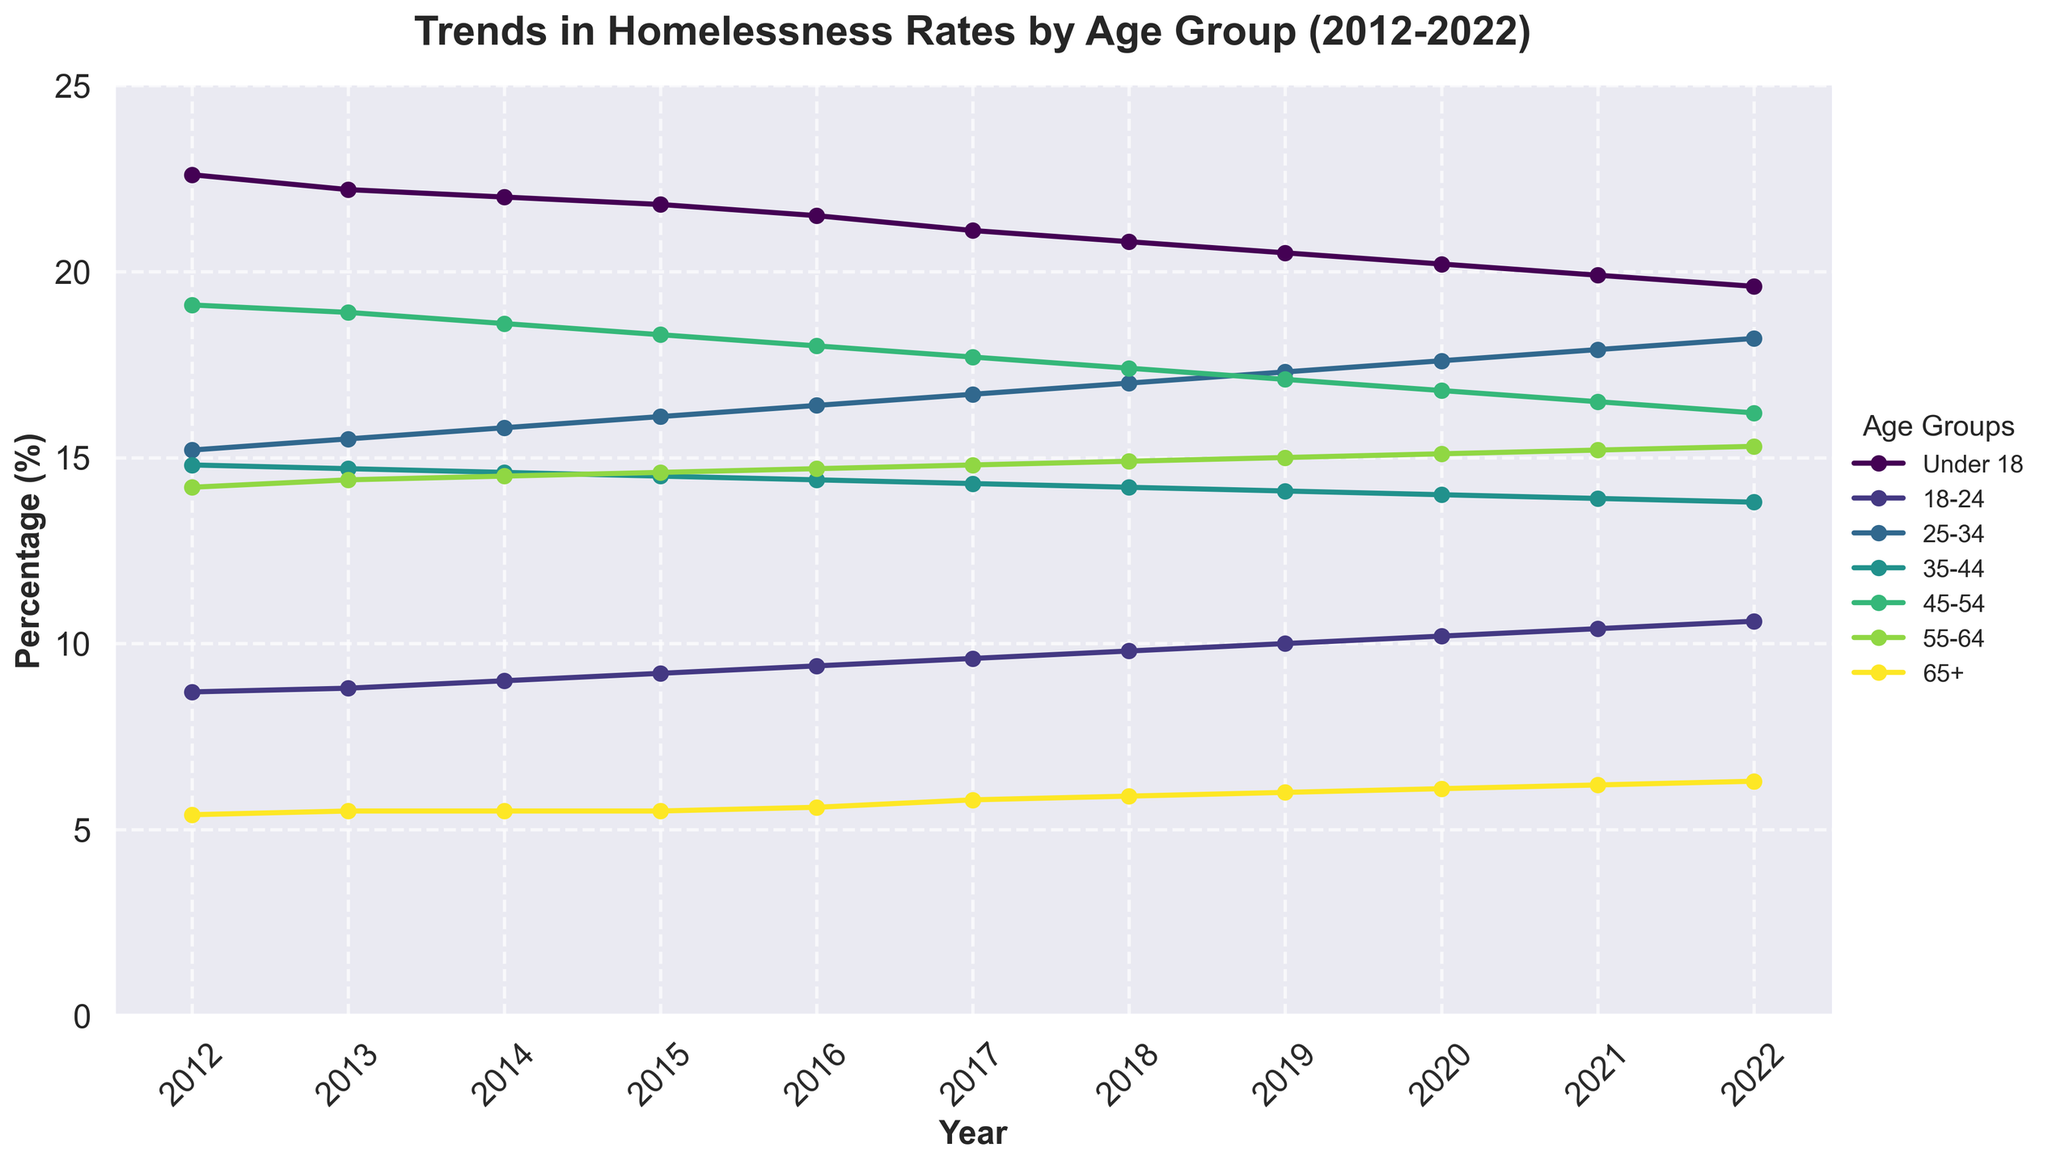What is the trend in homelessness rates for the 'Under 18' age group from 2012 to 2022? Look at the line representing the 'Under 18' age group on the graph. Observe its direction from 2012 to 2022, noting if it's generally increasing, decreasing, or stable.
Answer: Decreasing Which age group had the highest homelessness rate in 2012? Locate the year 2012 on the x-axis and look at the data points for each age group. Identify the age group with the highest data point.
Answer: Under 18 Between which years did the '18-24' age group see the highest increase in homelessness rate? Examine the line representing the '18-24' age group. Identify consecutive years where the line ascends the most steeply.
Answer: 2018 to 2019 Which two age groups had the closest homelessness rates in 2022? Locate the year 2022 on the x-axis. Compare the data points for all age groups and identify the two age groups with the most similar rates.
Answer: 25-34 and 45-54 By how much did the homelessness rate for the '45-54' age group decrease from 2012 to 2022? Find the data points for the '45-54' age group in 2012 and 2022. Subtract the 2022 value from the 2012 value.
Answer: 19.1% - 16.2% = 2.9% Which age group had a steady increase in homelessness rates over the entire decade? Examine the lines for each age group and identify any line that consistently rises from 2012 to 2022 without any dips.
Answer: 65+ What is the average homelessness rate for the '25-34' age group over the decade? Sum the homelessness rates for the '25-34' age group from 2012 to 2022. Divide the sum by the number of years (11).
Answer: (15.2+15.5+15.8+16.1+16.4+16.7+17.0+17.3+17.6+17.9+18.2)/11 = 16.482% Which age group showed the least change in homelessness rates from 2012 to 2022? Look at the lines representing the homelessness rates for all age groups. Identify the line that remained the most stable with minimal fluctuations.
Answer: 55-64 How did the homelessness rate for the '65+' age group change from 2012 to 2022? Observe the data points for the '65+' age group from 2012 to 2022. Note the general direction and any significant changes over the years.
Answer: Increased During which year was the difference between the 'Under 18' and '55-64' age groups the smallest? For each year, calculate the absolute difference between the homelessness rates for the 'Under 18' and '55-64' age groups. Identify the year with the smallest difference.
Answer: 2022 